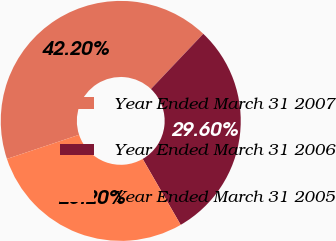Convert chart to OTSL. <chart><loc_0><loc_0><loc_500><loc_500><pie_chart><fcel>Year Ended March 31 2007<fcel>Year Ended March 31 2006<fcel>Year Ended March 31 2005<nl><fcel>42.2%<fcel>29.6%<fcel>28.2%<nl></chart> 